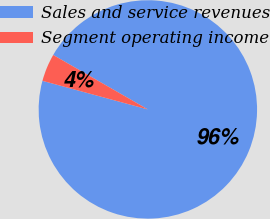<chart> <loc_0><loc_0><loc_500><loc_500><pie_chart><fcel>Sales and service revenues<fcel>Segment operating income<nl><fcel>95.91%<fcel>4.09%<nl></chart> 